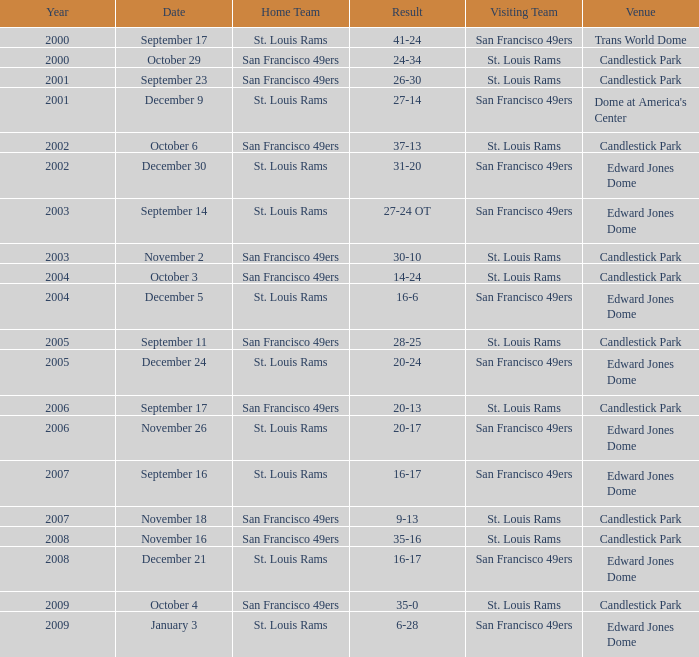What is the Result of the game on October 3? 14-24. 